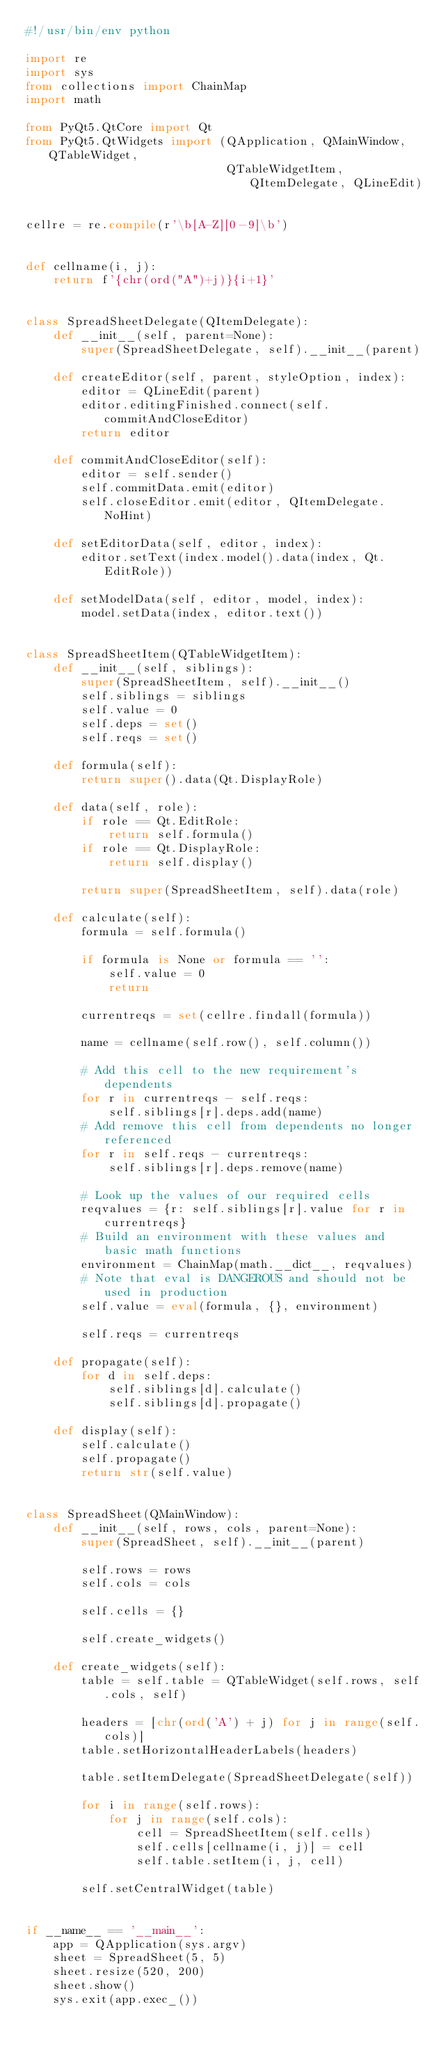<code> <loc_0><loc_0><loc_500><loc_500><_Python_>#!/usr/bin/env python

import re
import sys
from collections import ChainMap
import math

from PyQt5.QtCore import Qt
from PyQt5.QtWidgets import (QApplication, QMainWindow, QTableWidget,
                             QTableWidgetItem, QItemDelegate, QLineEdit)


cellre = re.compile(r'\b[A-Z][0-9]\b')


def cellname(i, j):
    return f'{chr(ord("A")+j)}{i+1}'


class SpreadSheetDelegate(QItemDelegate):
    def __init__(self, parent=None):
        super(SpreadSheetDelegate, self).__init__(parent)

    def createEditor(self, parent, styleOption, index):
        editor = QLineEdit(parent)
        editor.editingFinished.connect(self.commitAndCloseEditor)
        return editor

    def commitAndCloseEditor(self):
        editor = self.sender()
        self.commitData.emit(editor)
        self.closeEditor.emit(editor, QItemDelegate.NoHint)

    def setEditorData(self, editor, index):
        editor.setText(index.model().data(index, Qt.EditRole))

    def setModelData(self, editor, model, index):
        model.setData(index, editor.text())


class SpreadSheetItem(QTableWidgetItem):
    def __init__(self, siblings):
        super(SpreadSheetItem, self).__init__()
        self.siblings = siblings
        self.value = 0
        self.deps = set()
        self.reqs = set()

    def formula(self):
        return super().data(Qt.DisplayRole)

    def data(self, role):
        if role == Qt.EditRole:
            return self.formula()
        if role == Qt.DisplayRole:
            return self.display()

        return super(SpreadSheetItem, self).data(role)

    def calculate(self):
        formula = self.formula()

        if formula is None or formula == '':
            self.value = 0
            return

        currentreqs = set(cellre.findall(formula))

        name = cellname(self.row(), self.column())

        # Add this cell to the new requirement's dependents
        for r in currentreqs - self.reqs:
            self.siblings[r].deps.add(name)
        # Add remove this cell from dependents no longer referenced
        for r in self.reqs - currentreqs:
            self.siblings[r].deps.remove(name)

        # Look up the values of our required cells
        reqvalues = {r: self.siblings[r].value for r in currentreqs}
        # Build an environment with these values and basic math functions
        environment = ChainMap(math.__dict__, reqvalues)
        # Note that eval is DANGEROUS and should not be used in production
        self.value = eval(formula, {}, environment)

        self.reqs = currentreqs

    def propagate(self):
        for d in self.deps:
            self.siblings[d].calculate()
            self.siblings[d].propagate()

    def display(self):
        self.calculate()
        self.propagate()
        return str(self.value)


class SpreadSheet(QMainWindow):
    def __init__(self, rows, cols, parent=None):
        super(SpreadSheet, self).__init__(parent)

        self.rows = rows
        self.cols = cols

        self.cells = {}

        self.create_widgets()

    def create_widgets(self):
        table = self.table = QTableWidget(self.rows, self.cols, self)

        headers = [chr(ord('A') + j) for j in range(self.cols)]
        table.setHorizontalHeaderLabels(headers)

        table.setItemDelegate(SpreadSheetDelegate(self))

        for i in range(self.rows):
            for j in range(self.cols):
                cell = SpreadSheetItem(self.cells)
                self.cells[cellname(i, j)] = cell
                self.table.setItem(i, j, cell)

        self.setCentralWidget(table)


if __name__ == '__main__':
    app = QApplication(sys.argv)
    sheet = SpreadSheet(5, 5)
    sheet.resize(520, 200)
    sheet.show()
    sys.exit(app.exec_())
</code> 